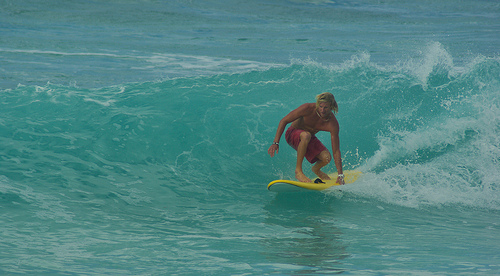Who is wearing a bracelet? The surfer, who is expertly navigating the wave, is wearing a bracelet, possibly as a stylish personal accessory. 